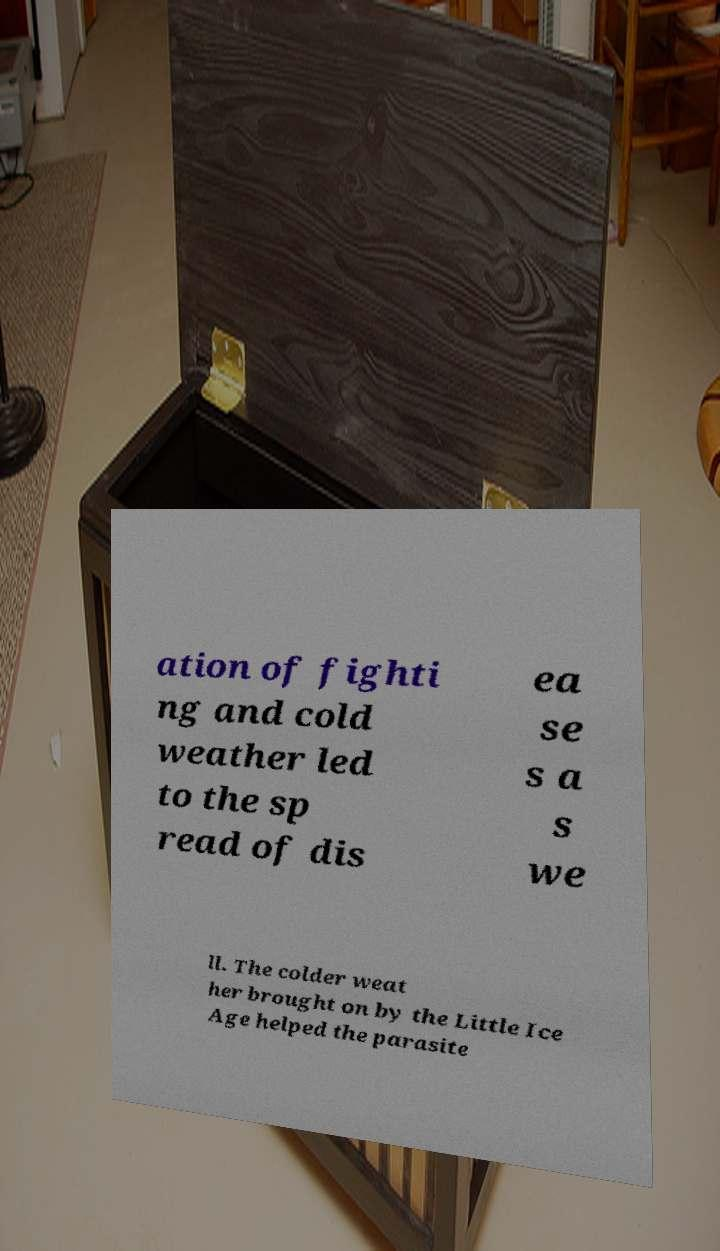Please identify and transcribe the text found in this image. ation of fighti ng and cold weather led to the sp read of dis ea se s a s we ll. The colder weat her brought on by the Little Ice Age helped the parasite 